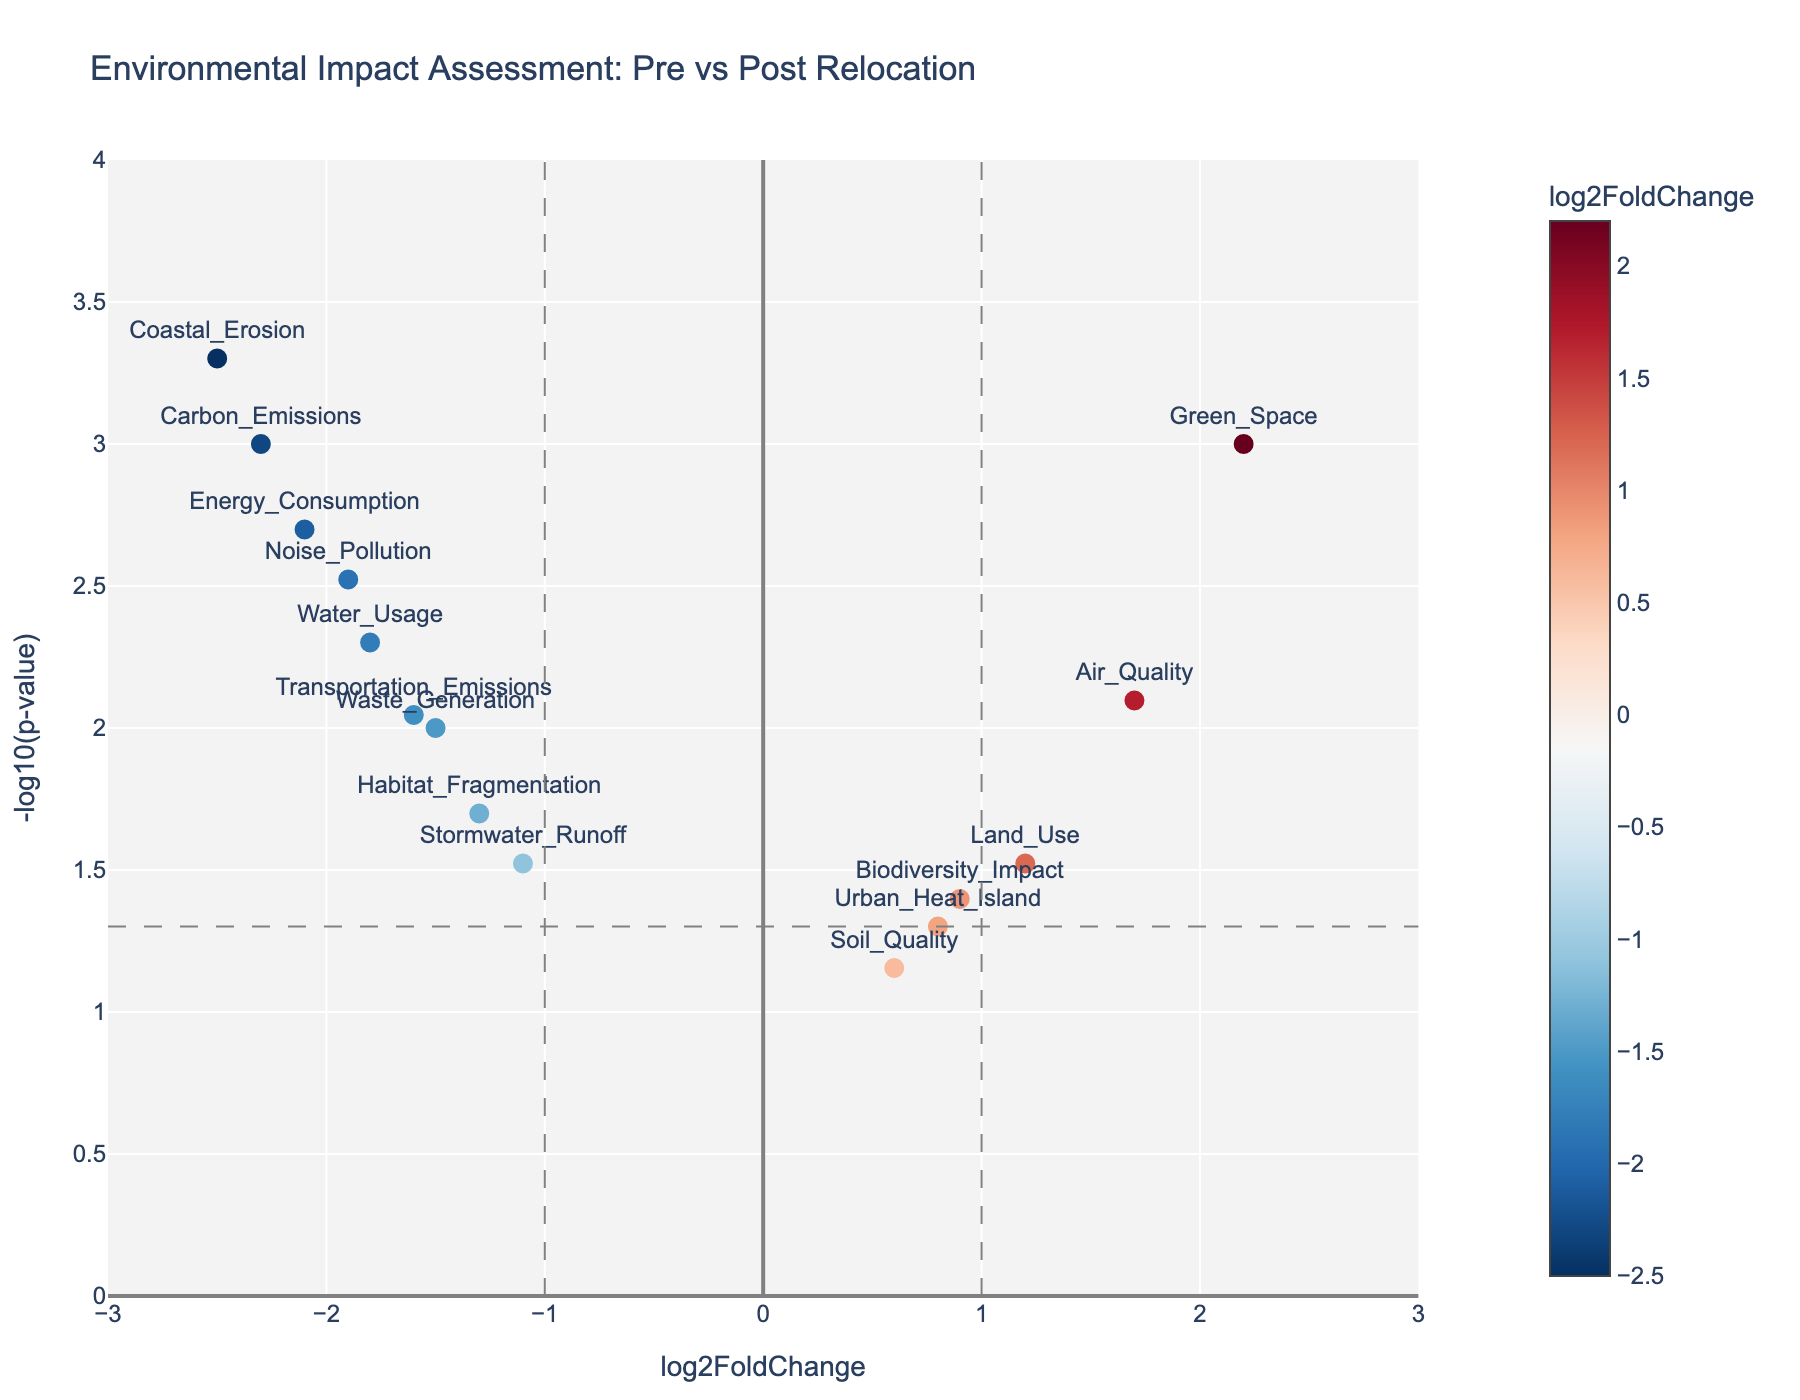What's the title of the plot? The title of the plot can be found at the top center of the figure.
Answer: Environmental Impact Assessment: Pre vs Post Relocation What is the color scale used in the figure? The color scale changes gradually based on the `log2FoldChange` values, ranging from blue for lower values to red for higher values.
Answer: RdBu_r How many environmental factors have a positive log2FoldChange? We need to count the data points where the `log2FoldChange` value is greater than 0.
Answer: 5 Which environmental factor has the most significant reduction in ecological footprint? The most significant reduction would be indicated by the most negative `log2FoldChange` and highest `-log10(pvalue)`. Observing the plot, we see Coastal_Erosion has the most negative value.
Answer: Coastal_Erosion Is the change in Air Quality statistically significant (p-value < 0.05)? Check the y-axis value for Air_Quality; if it is above the horizontal line for the threshold (-log10(0.05)), it means it's statistically significant.
Answer: Yes What is the approximate `-log10(p-value)` for Green Space? Find the `-log10(pvalue)` of the data point labeled Green_Space by locating its position on the y-axis.
Answer: 3 Which environmental factor shows the highest increase in impact post-relocation? To determine the highest increase, look for the data point with the highest positive `log2FoldChange`.
Answer: Green_Space How many data points lie within the interval -2 <= log2FoldChange <= 2 and have a p-value < 0.05? Count the points within the specified log2FoldChange range and above the horizontal line representing p-value < 0.05.
Answer: 10 Compare the ecological footprint change in Energy Consumption and Waste Generation. Which has a greater reduction? Energy_Consumption has a more negative `log2FoldChange` compared to Waste_Generation.
Answer: Energy_Consumption 